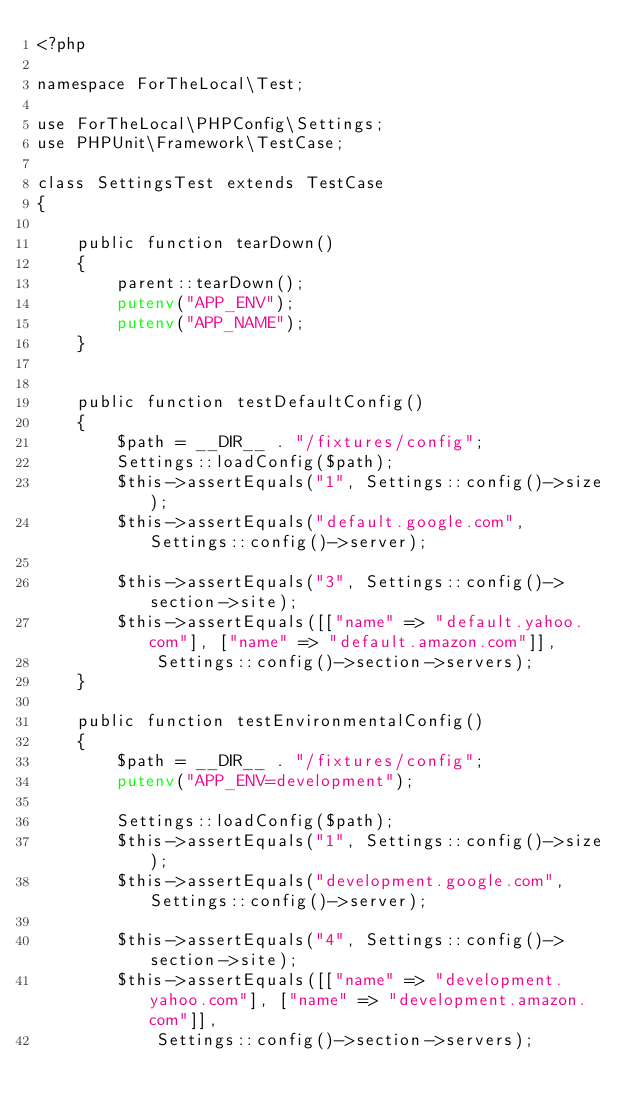<code> <loc_0><loc_0><loc_500><loc_500><_PHP_><?php

namespace ForTheLocal\Test;

use ForTheLocal\PHPConfig\Settings;
use PHPUnit\Framework\TestCase;

class SettingsTest extends TestCase
{

    public function tearDown()
    {
        parent::tearDown();
        putenv("APP_ENV");
        putenv("APP_NAME");
    }


    public function testDefaultConfig()
    {
        $path = __DIR__ . "/fixtures/config";
        Settings::loadConfig($path);
        $this->assertEquals("1", Settings::config()->size);
        $this->assertEquals("default.google.com", Settings::config()->server);

        $this->assertEquals("3", Settings::config()->section->site);
        $this->assertEquals([["name" => "default.yahoo.com"], ["name" => "default.amazon.com"]],
            Settings::config()->section->servers);
    }

    public function testEnvironmentalConfig()
    {
        $path = __DIR__ . "/fixtures/config";
        putenv("APP_ENV=development");

        Settings::loadConfig($path);
        $this->assertEquals("1", Settings::config()->size);
        $this->assertEquals("development.google.com", Settings::config()->server);

        $this->assertEquals("4", Settings::config()->section->site);
        $this->assertEquals([["name" => "development.yahoo.com"], ["name" => "development.amazon.com"]],
            Settings::config()->section->servers);
</code> 